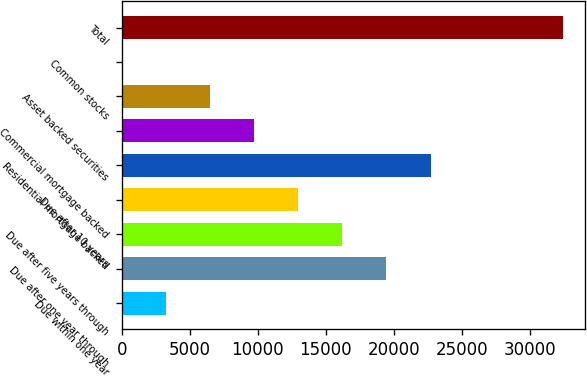<chart> <loc_0><loc_0><loc_500><loc_500><bar_chart><fcel>Due within one year<fcel>Due after one year through<fcel>Due after five years through<fcel>Due after 10 years<fcel>Residential mortgage backed<fcel>Commercial mortgage backed<fcel>Asset backed securities<fcel>Common stocks<fcel>Total<nl><fcel>3249.2<fcel>19470.2<fcel>16226<fcel>12981.8<fcel>22714.4<fcel>9737.6<fcel>6493.4<fcel>5<fcel>32447<nl></chart> 